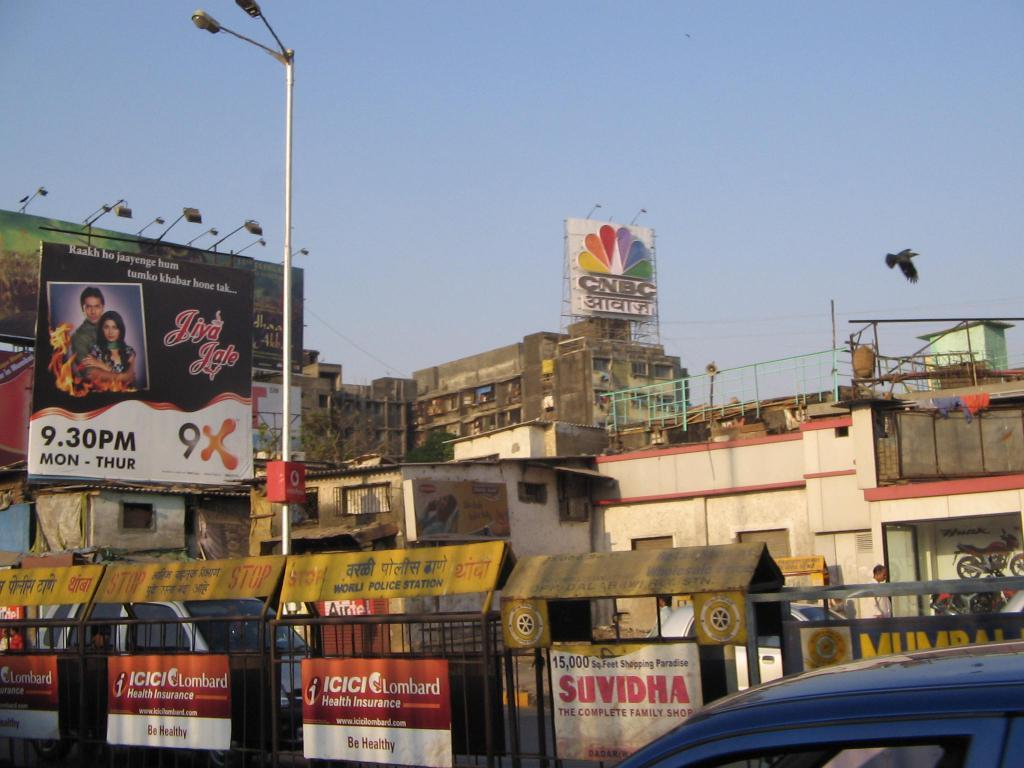<image>
Share a concise interpretation of the image provided. A CNBC stands atop a building looking down over a very dense indian city. 